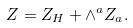<formula> <loc_0><loc_0><loc_500><loc_500>Z = Z _ { H } + \wedge ^ { a } Z _ { a } .</formula> 